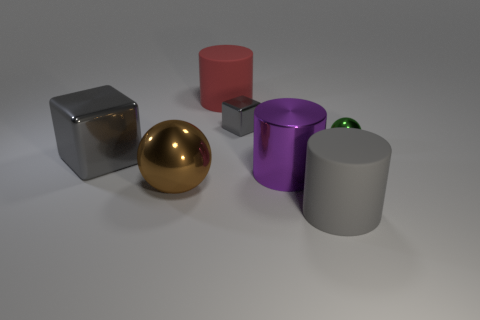Subtract all big matte cylinders. How many cylinders are left? 1 Add 3 large red matte cubes. How many objects exist? 10 Subtract all big blue rubber balls. Subtract all red rubber objects. How many objects are left? 6 Add 5 red cylinders. How many red cylinders are left? 6 Add 7 metal balls. How many metal balls exist? 9 Subtract all brown balls. How many balls are left? 1 Subtract 0 brown cylinders. How many objects are left? 7 Subtract all blocks. How many objects are left? 5 Subtract 3 cylinders. How many cylinders are left? 0 Subtract all brown balls. Subtract all blue blocks. How many balls are left? 1 